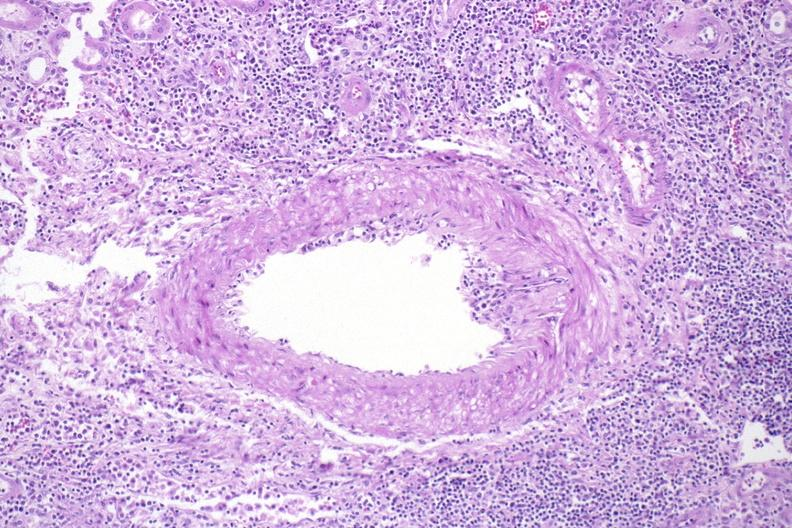where is this?
Answer the question using a single word or phrase. Urinary 